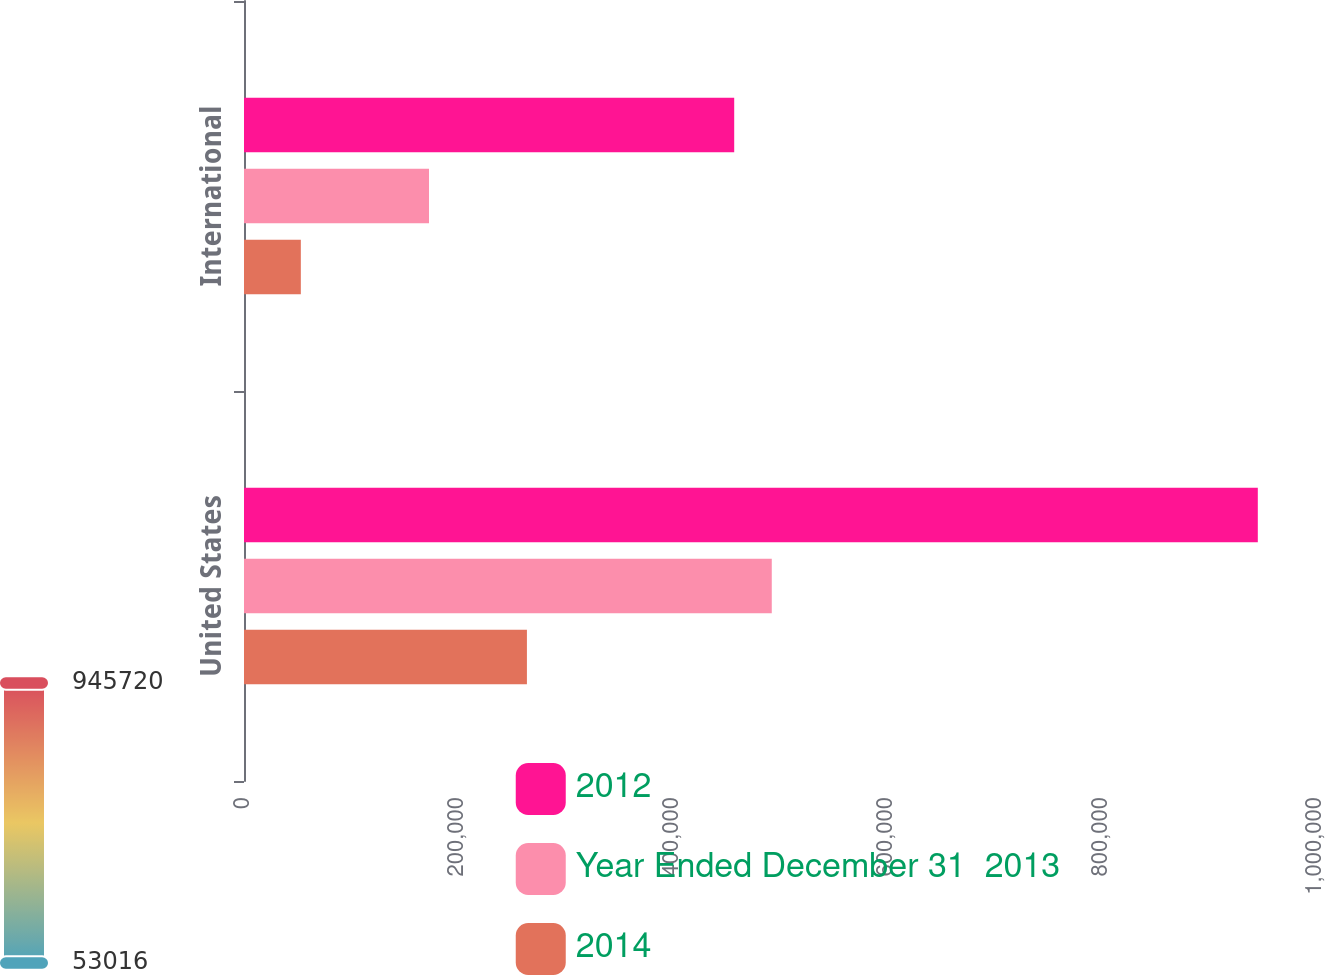<chart> <loc_0><loc_0><loc_500><loc_500><stacked_bar_chart><ecel><fcel>United States<fcel>International<nl><fcel>2012<fcel>945720<fcel>457282<nl><fcel>Year Ended December 31  2013<fcel>492320<fcel>172570<nl><fcel>2014<fcel>263917<fcel>53016<nl></chart> 